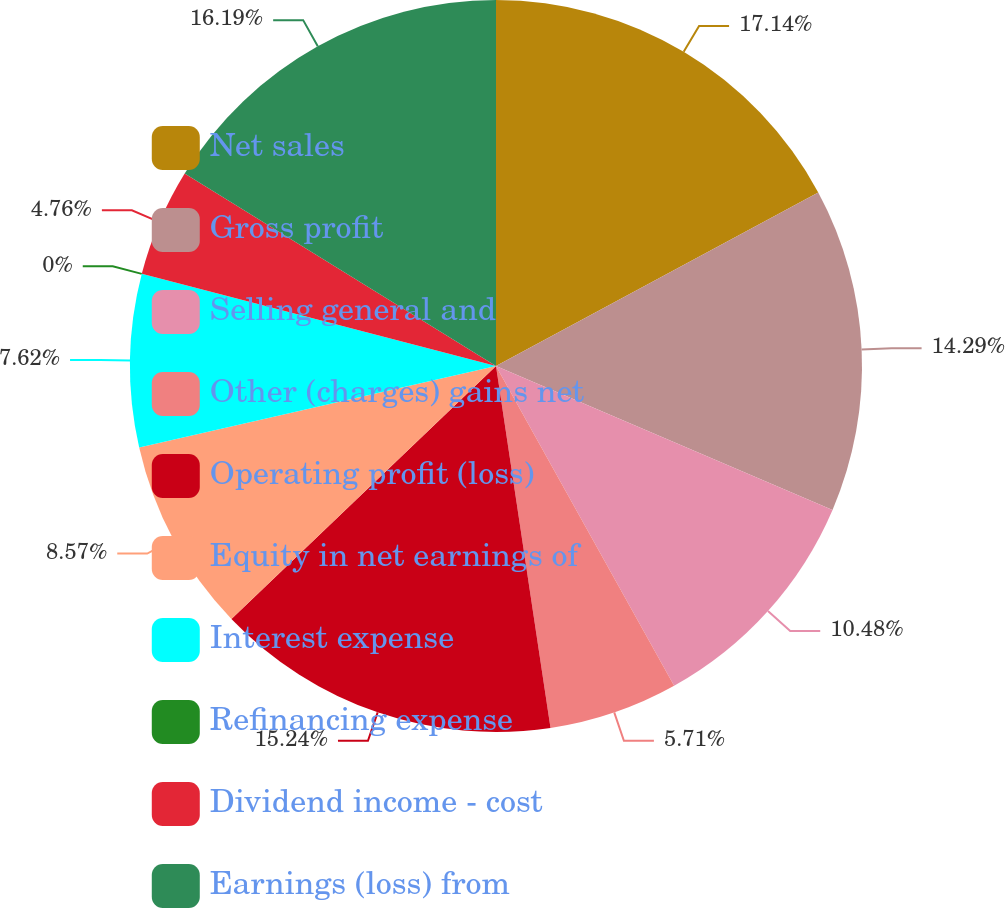Convert chart to OTSL. <chart><loc_0><loc_0><loc_500><loc_500><pie_chart><fcel>Net sales<fcel>Gross profit<fcel>Selling general and<fcel>Other (charges) gains net<fcel>Operating profit (loss)<fcel>Equity in net earnings of<fcel>Interest expense<fcel>Refinancing expense<fcel>Dividend income - cost<fcel>Earnings (loss) from<nl><fcel>17.14%<fcel>14.29%<fcel>10.48%<fcel>5.71%<fcel>15.24%<fcel>8.57%<fcel>7.62%<fcel>0.0%<fcel>4.76%<fcel>16.19%<nl></chart> 